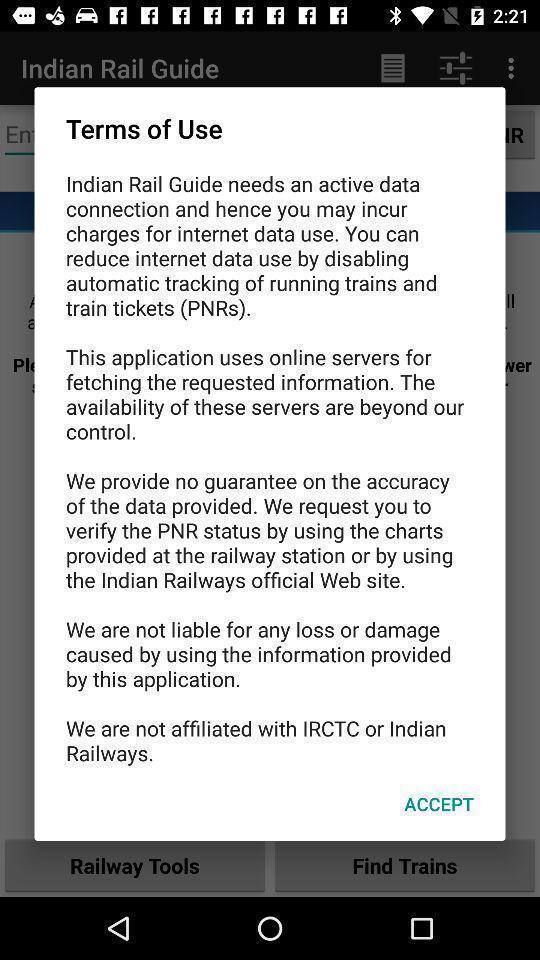Tell me about the visual elements in this screen capture. Pop-up shows terms of a transport application. 